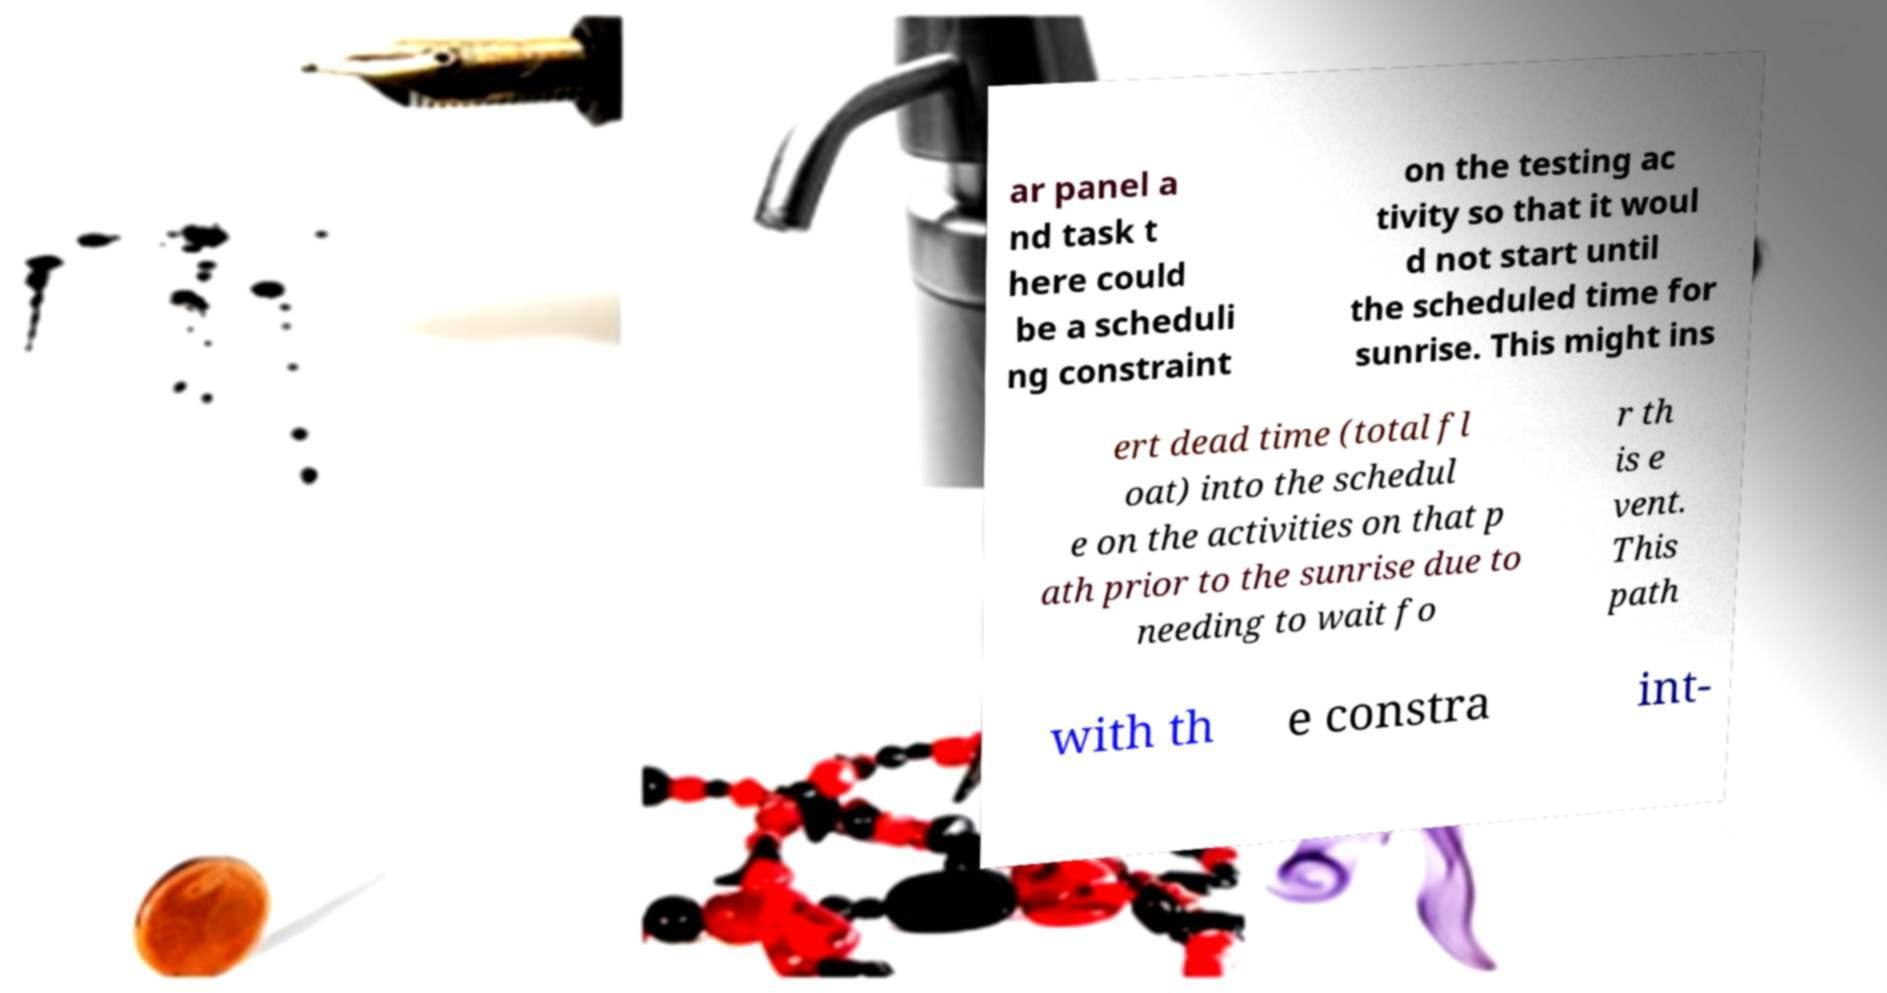Could you assist in decoding the text presented in this image and type it out clearly? ar panel a nd task t here could be a scheduli ng constraint on the testing ac tivity so that it woul d not start until the scheduled time for sunrise. This might ins ert dead time (total fl oat) into the schedul e on the activities on that p ath prior to the sunrise due to needing to wait fo r th is e vent. This path with th e constra int- 